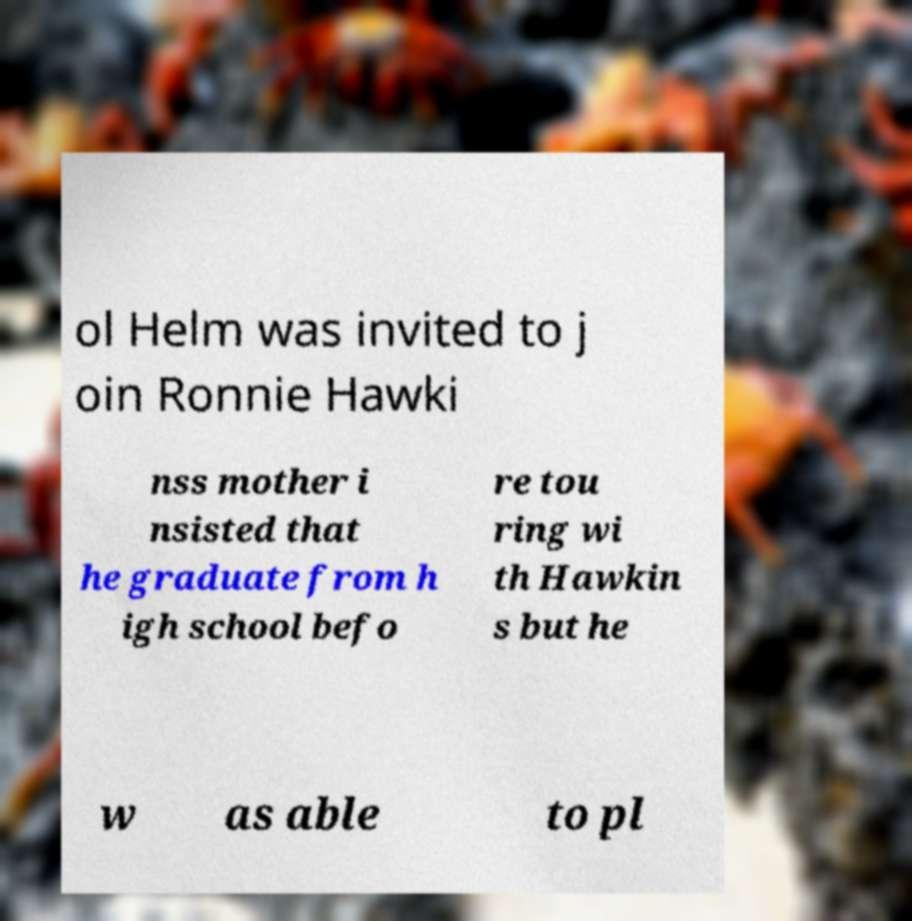I need the written content from this picture converted into text. Can you do that? ol Helm was invited to j oin Ronnie Hawki nss mother i nsisted that he graduate from h igh school befo re tou ring wi th Hawkin s but he w as able to pl 